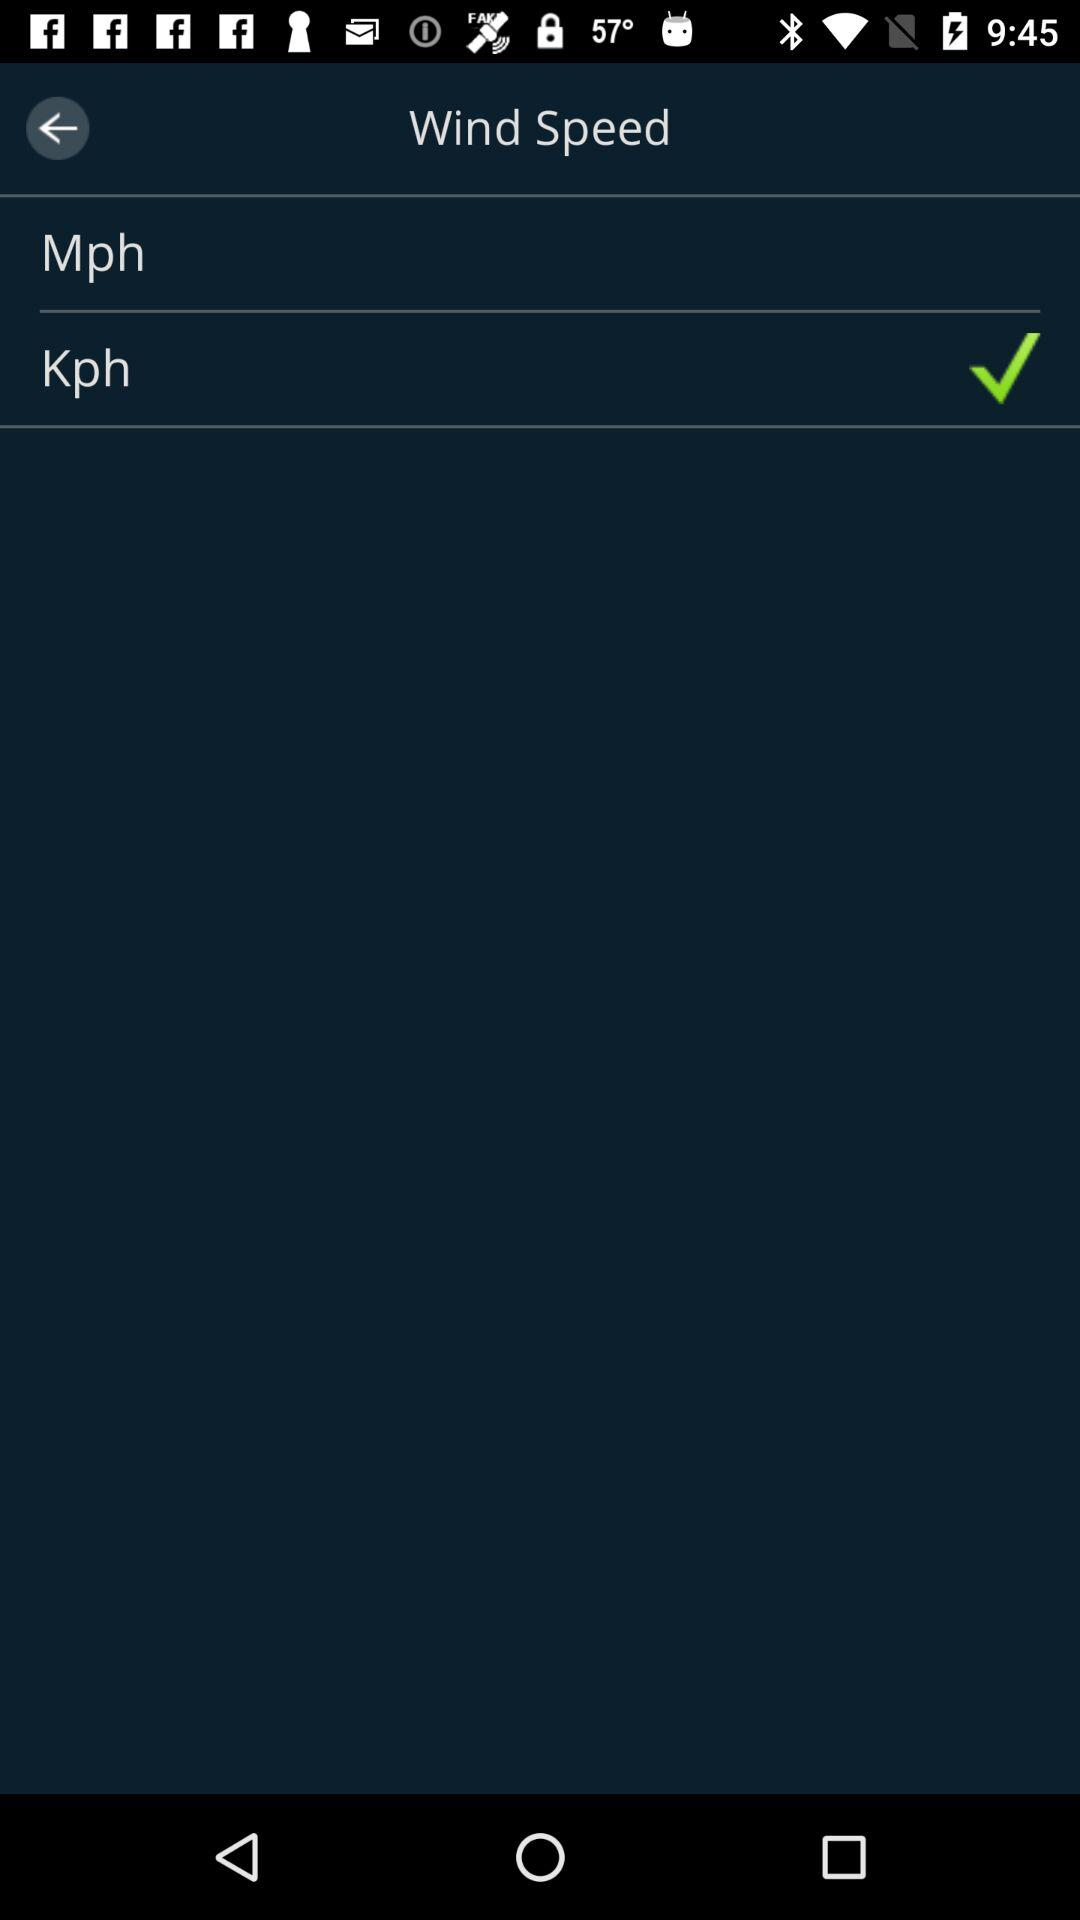What is the selected unit for measuring wind speed? The selected unit is "Kph". 